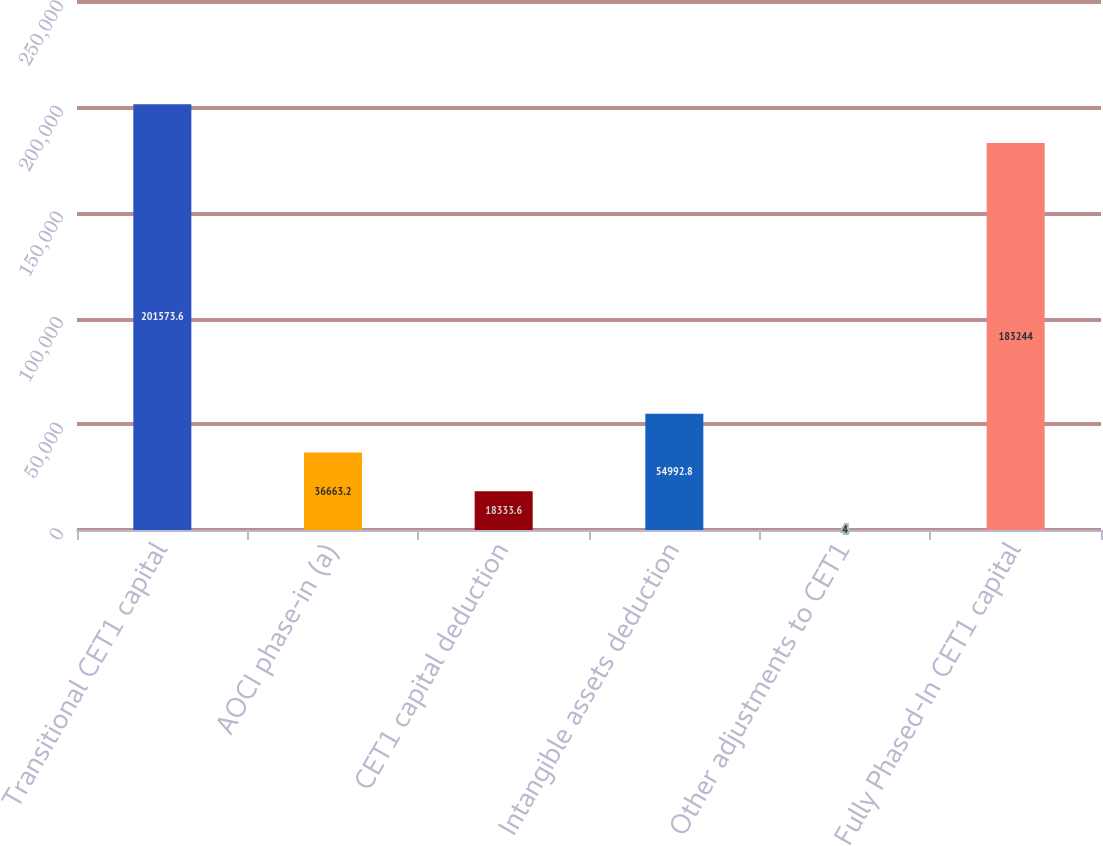<chart> <loc_0><loc_0><loc_500><loc_500><bar_chart><fcel>Transitional CET1 capital<fcel>AOCI phase-in (a)<fcel>CET1 capital deduction<fcel>Intangible assets deduction<fcel>Other adjustments to CET1<fcel>Fully Phased-In CET1 capital<nl><fcel>201574<fcel>36663.2<fcel>18333.6<fcel>54992.8<fcel>4<fcel>183244<nl></chart> 